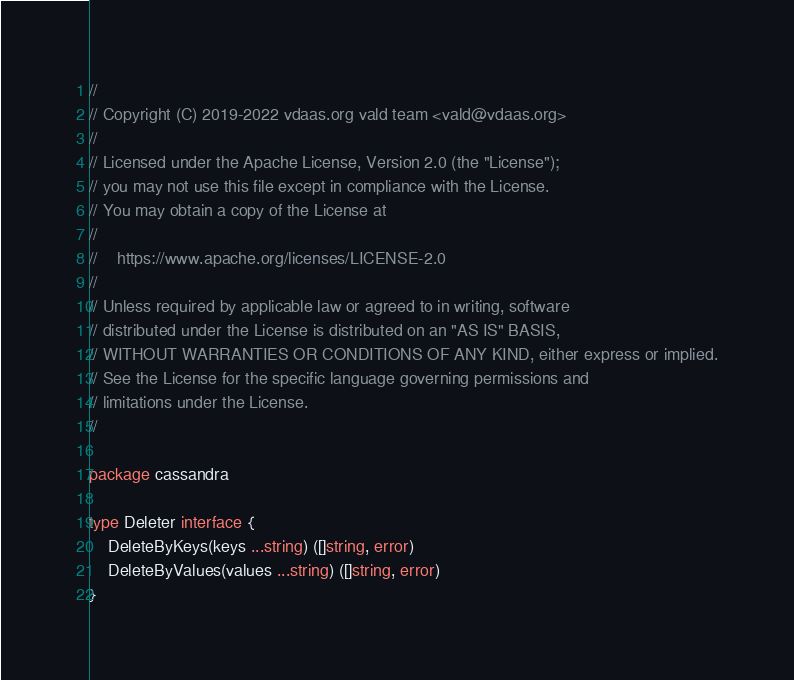Convert code to text. <code><loc_0><loc_0><loc_500><loc_500><_Go_>//
// Copyright (C) 2019-2022 vdaas.org vald team <vald@vdaas.org>
//
// Licensed under the Apache License, Version 2.0 (the "License");
// you may not use this file except in compliance with the License.
// You may obtain a copy of the License at
//
//    https://www.apache.org/licenses/LICENSE-2.0
//
// Unless required by applicable law or agreed to in writing, software
// distributed under the License is distributed on an "AS IS" BASIS,
// WITHOUT WARRANTIES OR CONDITIONS OF ANY KIND, either express or implied.
// See the License for the specific language governing permissions and
// limitations under the License.
//

package cassandra

type Deleter interface {
	DeleteByKeys(keys ...string) ([]string, error)
	DeleteByValues(values ...string) ([]string, error)
}
</code> 